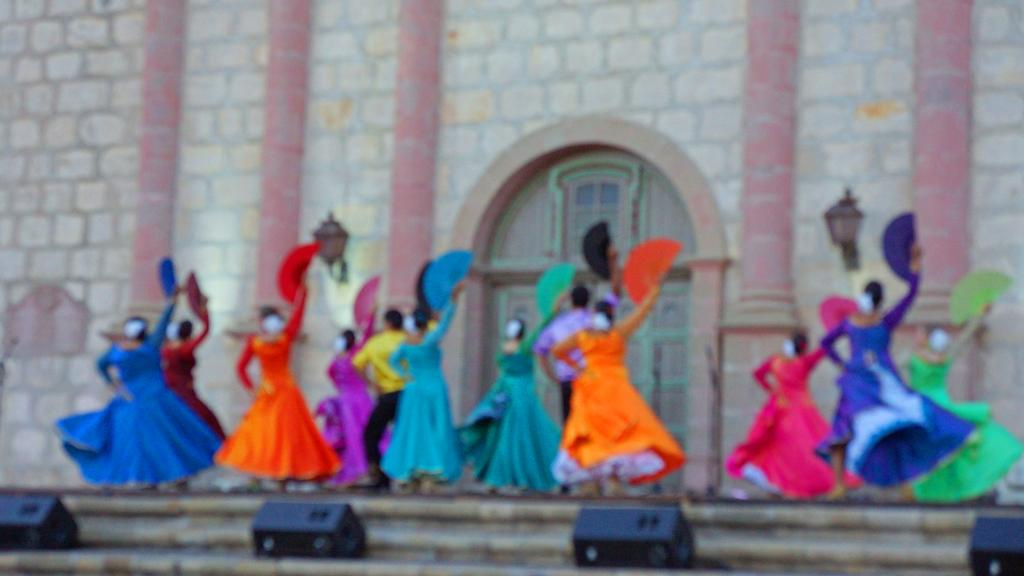How many people are in the image? There are people in the image, but the exact number is not specified. What are the people wearing? The people are wearing clothes. What activity are the people engaged in? The people are dancing. What can be seen in the background of the image? There is a wall in the image, and there is a door in the middle of the image. What is present at the bottom of the image? There are lights at the bottom of the image. What type of produce can be seen growing on the wall in the image? There is no produce growing on the wall in the image; it is a wall with a door in the middle. How many frogs are present in the image? There are no frogs present in the image; it features people dancing and a wall with a door. 